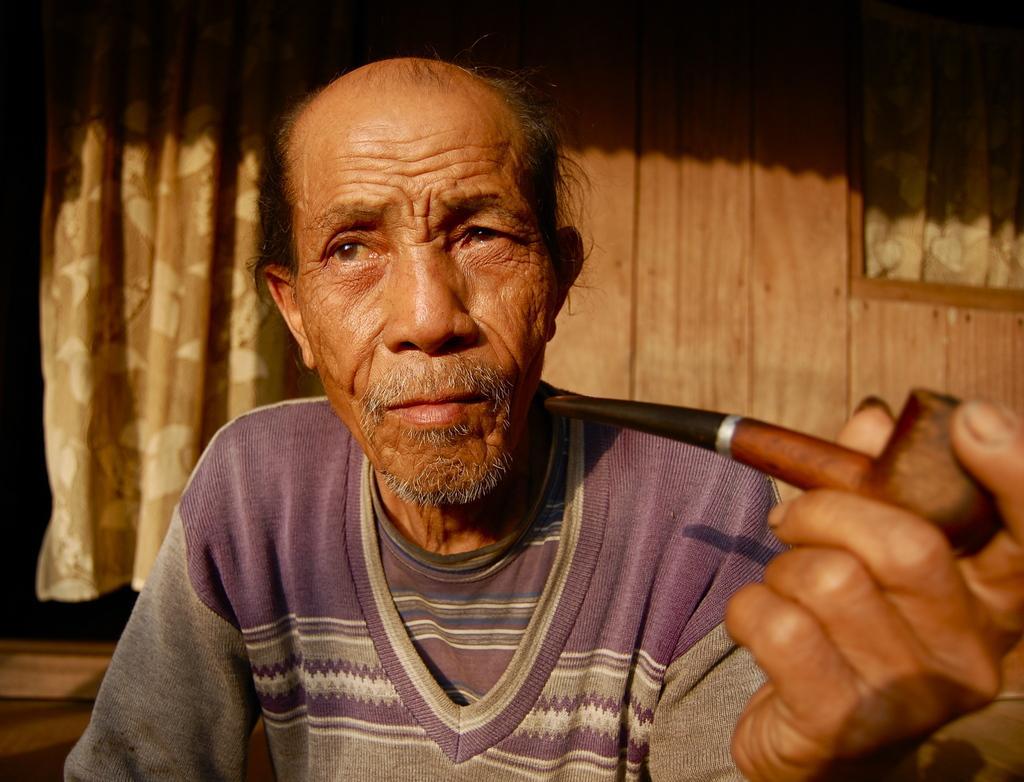Please provide a concise description of this image. In the middle of the image, there is a person holding a smoking pipe with one hand. In the background, there is a curtain and there is a wooden wall which is having a window. 